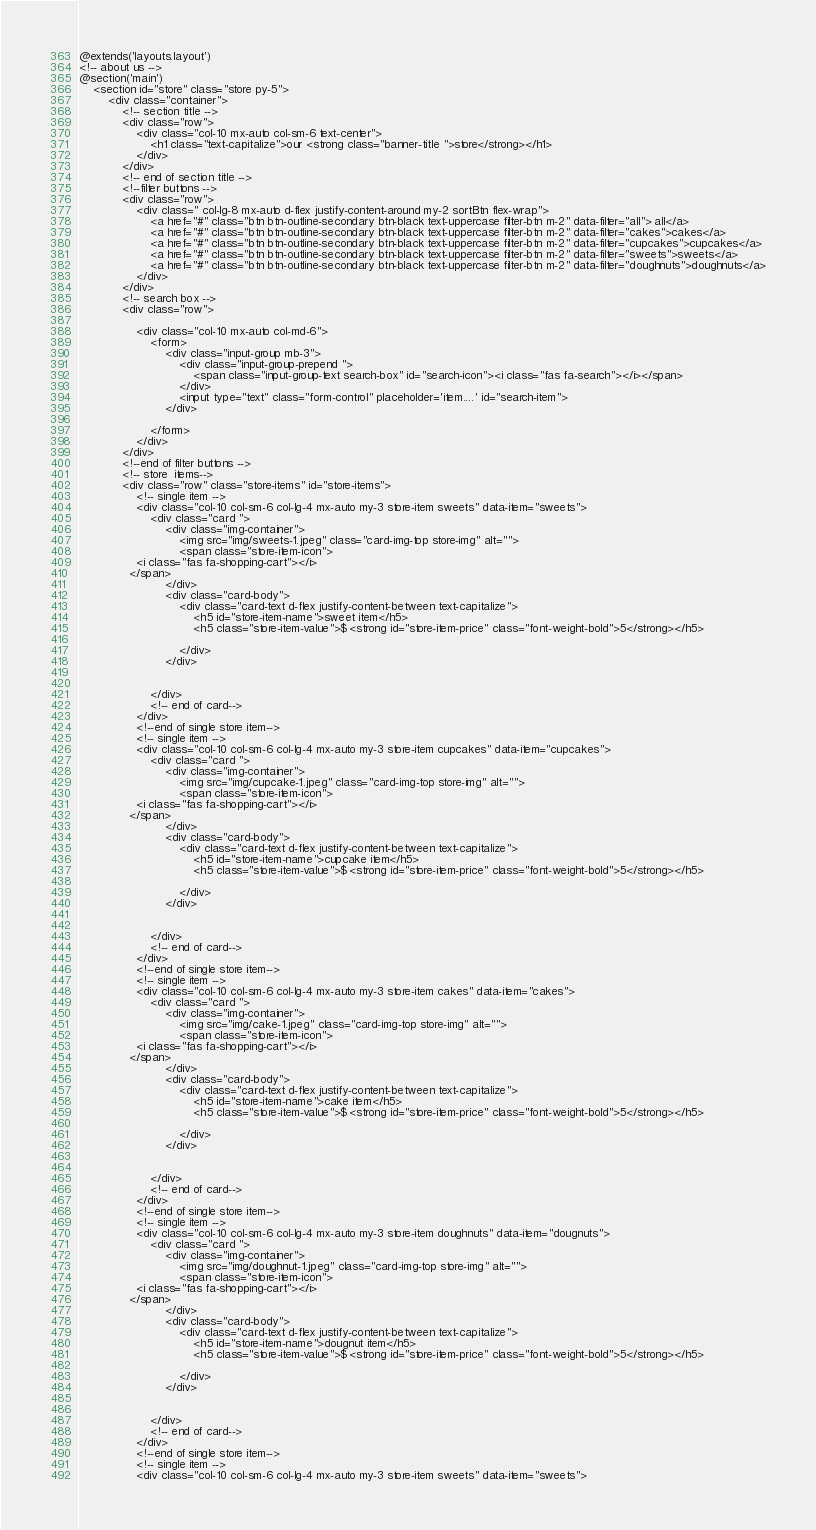Convert code to text. <code><loc_0><loc_0><loc_500><loc_500><_PHP_>@extends('layouts.layout')
<!-- about us -->
@section('main')
    <section id="store" class="store py-5">
        <div class="container">
            <!-- section title -->
            <div class="row">
                <div class="col-10 mx-auto col-sm-6 text-center">
                    <h1 class="text-capitalize">our <strong class="banner-title ">store</strong></h1>
                </div>
            </div>
            <!-- end of section title -->
            <!--filter buttons -->
            <div class="row">
                <div class=" col-lg-8 mx-auto d-flex justify-content-around my-2 sortBtn flex-wrap">
                    <a href="#" class="btn btn-outline-secondary btn-black text-uppercase filter-btn m-2" data-filter="all"> all</a>
                    <a href="#" class="btn btn-outline-secondary btn-black text-uppercase filter-btn m-2" data-filter="cakes">cakes</a>
                    <a href="#" class="btn btn-outline-secondary btn-black text-uppercase filter-btn m-2" data-filter="cupcakes">cupcakes</a>
                    <a href="#" class="btn btn-outline-secondary btn-black text-uppercase filter-btn m-2" data-filter="sweets">sweets</a>
                    <a href="#" class="btn btn-outline-secondary btn-black text-uppercase filter-btn m-2" data-filter="doughnuts">doughnuts</a>
                </div>
            </div>
            <!-- search box -->
            <div class="row">

                <div class="col-10 mx-auto col-md-6">
                    <form>
                        <div class="input-group mb-3">
                            <div class="input-group-prepend ">
                                <span class="input-group-text search-box" id="search-icon"><i class="fas fa-search"></i></span>
                            </div>
                            <input type="text" class="form-control" placeholder='item....' id="search-item">
                        </div>

                    </form>
                </div>
            </div>
            <!--end of filter buttons -->
            <!-- store  items-->
            <div class="row" class="store-items" id="store-items">
                <!-- single item -->
                <div class="col-10 col-sm-6 col-lg-4 mx-auto my-3 store-item sweets" data-item="sweets">
                    <div class="card ">
                        <div class="img-container">
                            <img src="img/sweets-1.jpeg" class="card-img-top store-img" alt="">
                            <span class="store-item-icon">
                <i class="fas fa-shopping-cart"></i>
              </span>
                        </div>
                        <div class="card-body">
                            <div class="card-text d-flex justify-content-between text-capitalize">
                                <h5 id="store-item-name">sweet item</h5>
                                <h5 class="store-item-value">$ <strong id="store-item-price" class="font-weight-bold">5</strong></h5>

                            </div>
                        </div>


                    </div>
                    <!-- end of card-->
                </div>
                <!--end of single store item-->
                <!-- single item -->
                <div class="col-10 col-sm-6 col-lg-4 mx-auto my-3 store-item cupcakes" data-item="cupcakes">
                    <div class="card ">
                        <div class="img-container">
                            <img src="img/cupcake-1.jpeg" class="card-img-top store-img" alt="">
                            <span class="store-item-icon">
                <i class="fas fa-shopping-cart"></i>
              </span>
                        </div>
                        <div class="card-body">
                            <div class="card-text d-flex justify-content-between text-capitalize">
                                <h5 id="store-item-name">cupcake item</h5>
                                <h5 class="store-item-value">$ <strong id="store-item-price" class="font-weight-bold">5</strong></h5>

                            </div>
                        </div>


                    </div>
                    <!-- end of card-->
                </div>
                <!--end of single store item-->
                <!-- single item -->
                <div class="col-10 col-sm-6 col-lg-4 mx-auto my-3 store-item cakes" data-item="cakes">
                    <div class="card ">
                        <div class="img-container">
                            <img src="img/cake-1.jpeg" class="card-img-top store-img" alt="">
                            <span class="store-item-icon">
                <i class="fas fa-shopping-cart"></i>
              </span>
                        </div>
                        <div class="card-body">
                            <div class="card-text d-flex justify-content-between text-capitalize">
                                <h5 id="store-item-name">cake item</h5>
                                <h5 class="store-item-value">$ <strong id="store-item-price" class="font-weight-bold">5</strong></h5>

                            </div>
                        </div>


                    </div>
                    <!-- end of card-->
                </div>
                <!--end of single store item-->
                <!-- single item -->
                <div class="col-10 col-sm-6 col-lg-4 mx-auto my-3 store-item doughnuts" data-item="dougnuts">
                    <div class="card ">
                        <div class="img-container">
                            <img src="img/doughnut-1.jpeg" class="card-img-top store-img" alt="">
                            <span class="store-item-icon">
                <i class="fas fa-shopping-cart"></i>
              </span>
                        </div>
                        <div class="card-body">
                            <div class="card-text d-flex justify-content-between text-capitalize">
                                <h5 id="store-item-name">dougnut item</h5>
                                <h5 class="store-item-value">$ <strong id="store-item-price" class="font-weight-bold">5</strong></h5>

                            </div>
                        </div>


                    </div>
                    <!-- end of card-->
                </div>
                <!--end of single store item-->
                <!-- single item -->
                <div class="col-10 col-sm-6 col-lg-4 mx-auto my-3 store-item sweets" data-item="sweets"></code> 